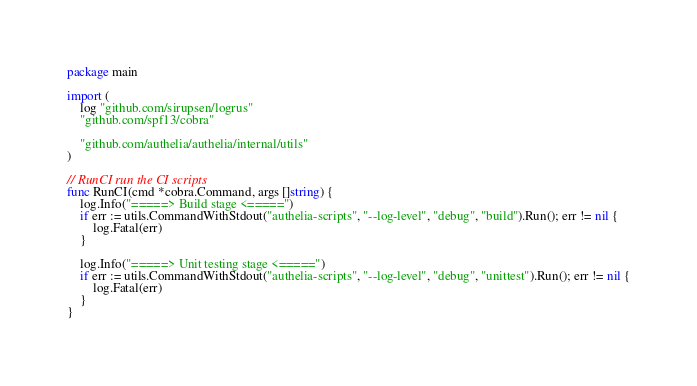<code> <loc_0><loc_0><loc_500><loc_500><_Go_>package main

import (
	log "github.com/sirupsen/logrus"
	"github.com/spf13/cobra"

	"github.com/authelia/authelia/internal/utils"
)

// RunCI run the CI scripts
func RunCI(cmd *cobra.Command, args []string) {
	log.Info("=====> Build stage <=====")
	if err := utils.CommandWithStdout("authelia-scripts", "--log-level", "debug", "build").Run(); err != nil {
		log.Fatal(err)
	}

	log.Info("=====> Unit testing stage <=====")
	if err := utils.CommandWithStdout("authelia-scripts", "--log-level", "debug", "unittest").Run(); err != nil {
		log.Fatal(err)
	}
}
</code> 